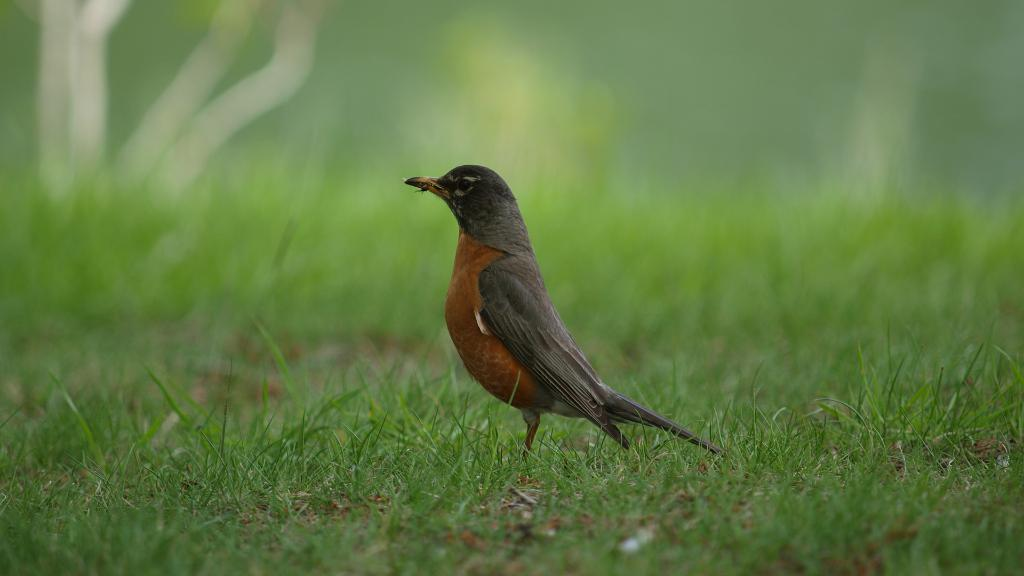What type of animal can be seen in the image? There is a bird in the image. What is the color of the grass in the image? The grass in the image is green. What type of street is visible in the image? There is no street present in the image; it features a bird and green grass. What type of coil or wire can be seen in the image? There is no coil or wire present in the image. 